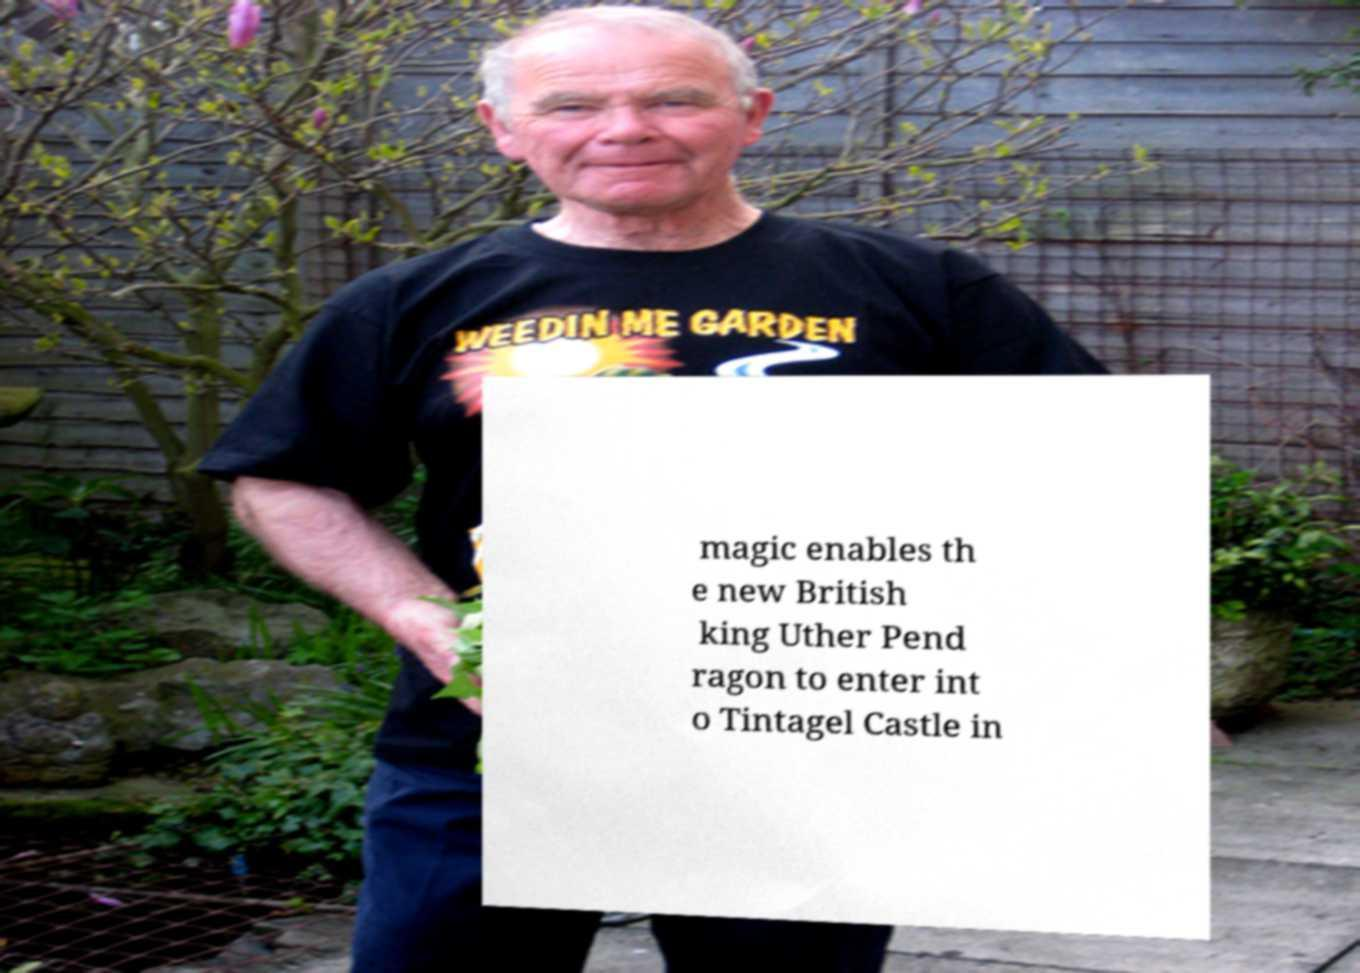Please identify and transcribe the text found in this image. magic enables th e new British king Uther Pend ragon to enter int o Tintagel Castle in 